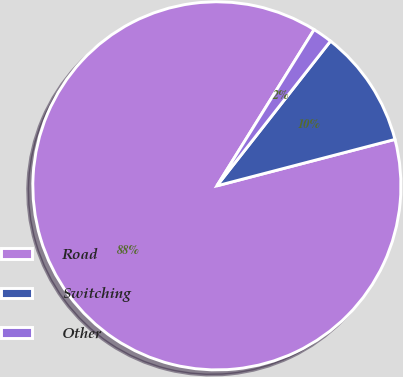Convert chart. <chart><loc_0><loc_0><loc_500><loc_500><pie_chart><fcel>Road<fcel>Switching<fcel>Other<nl><fcel>87.92%<fcel>10.35%<fcel>1.73%<nl></chart> 